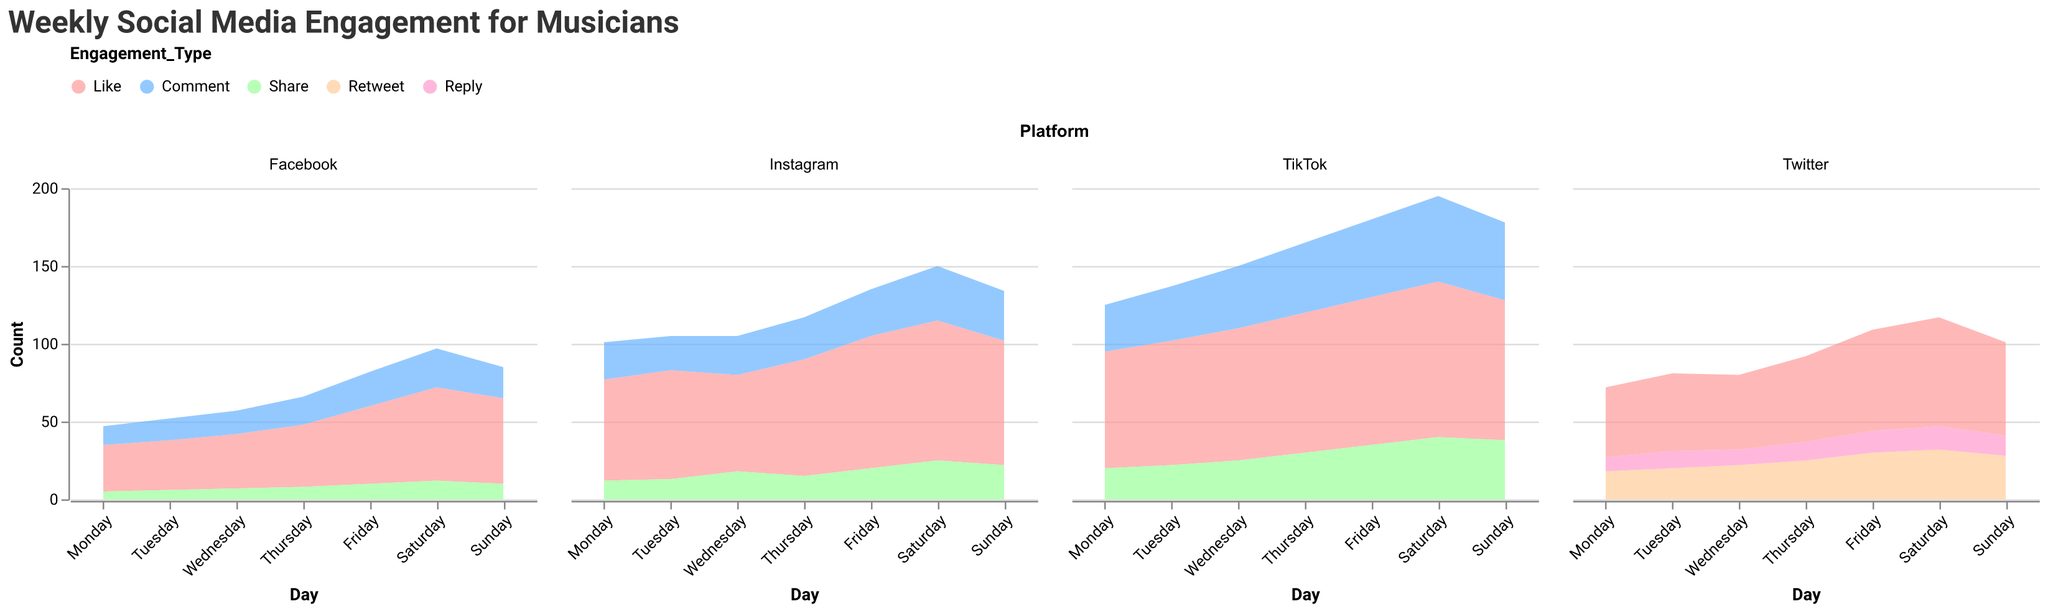What is the title of the figure? The title of the figure is displayed at the top and helps to give context to what the figure is depicting.
Answer: Weekly Social Media Engagement for Musicians What days of the week are displayed on the x-axis? The x-axis represents days of the week, which can be seen labeled from left to right for each subplot.
Answer: Monday, Tuesday, Wednesday, Thursday, Friday, Saturday, Sunday Which platform has the highest engagement on Saturday for likes? Look for the subplot related to Saturday and examine the area representing likes across all platforms.
Answer: TikTok What type of engagement on Facebook is the highest on Friday? Refer to the Friday data within the Facebook subplot, observing the different areas for types like Likes, Comments, and Shares.
Answer: Like How does the number of likes on Tuesday compare between Instagram and Twitter? Compare the height of the 'Like' areas for Tuesday on both Instagram and Twitter subplots.
Answer: Instagram has more likes Which day shows the maximum number of likes for TikTok? Look at the 'Like' area for TikTok on each day and identify the highest value.
Answer: Saturday What is the trend of comments on Instagram from Monday to Friday? Observe the size of the 'Comment' area on Instagram from Monday to Friday to determine if it's increasing, decreasing, or stable.
Answer: Increasing Which engagement type on Twitter has the smallest values across the week? Review the areas in the Twitter subplot and identify the engagement type with the smallest area consistently.
Answer: Reply Summing up all types of engagements, which day has the most overall engagement on Facebook? Add up the counts of Likes, Comments, and Shares on each day for Facebook and identify the day with the highest total.
Answer: Saturday On which day does Instagram show the peak number of shares? Examine the 'Share' area for Instagram across all days and locate the largest area.
Answer: Saturday 